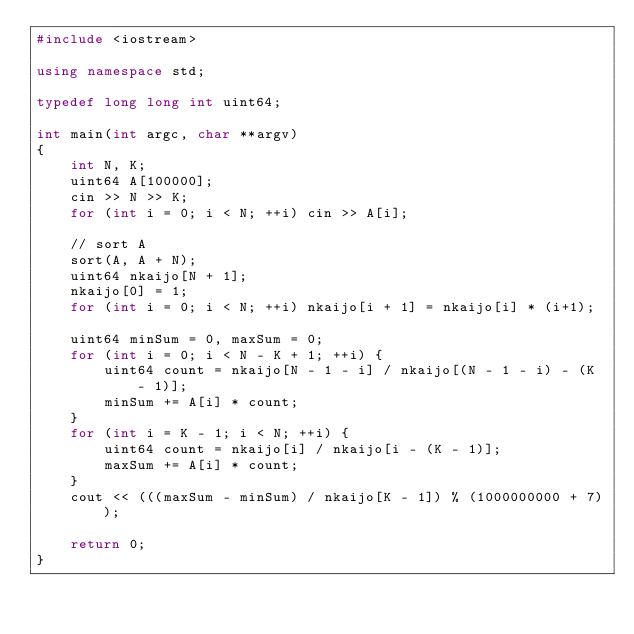<code> <loc_0><loc_0><loc_500><loc_500><_C++_>#include <iostream>

using namespace std;

typedef long long int uint64;

int main(int argc, char **argv)
{
    int N, K;
    uint64 A[100000];
    cin >> N >> K;
    for (int i = 0; i < N; ++i) cin >> A[i];

    // sort A
    sort(A, A + N);
    uint64 nkaijo[N + 1];
    nkaijo[0] = 1;
    for (int i = 0; i < N; ++i) nkaijo[i + 1] = nkaijo[i] * (i+1);

    uint64 minSum = 0, maxSum = 0;
    for (int i = 0; i < N - K + 1; ++i) {
        uint64 count = nkaijo[N - 1 - i] / nkaijo[(N - 1 - i) - (K - 1)];
        minSum += A[i] * count;
    }
    for (int i = K - 1; i < N; ++i) {
        uint64 count = nkaijo[i] / nkaijo[i - (K - 1)];
        maxSum += A[i] * count;
    }
    cout << (((maxSum - minSum) / nkaijo[K - 1]) % (1000000000 + 7));

    return 0;
}
</code> 